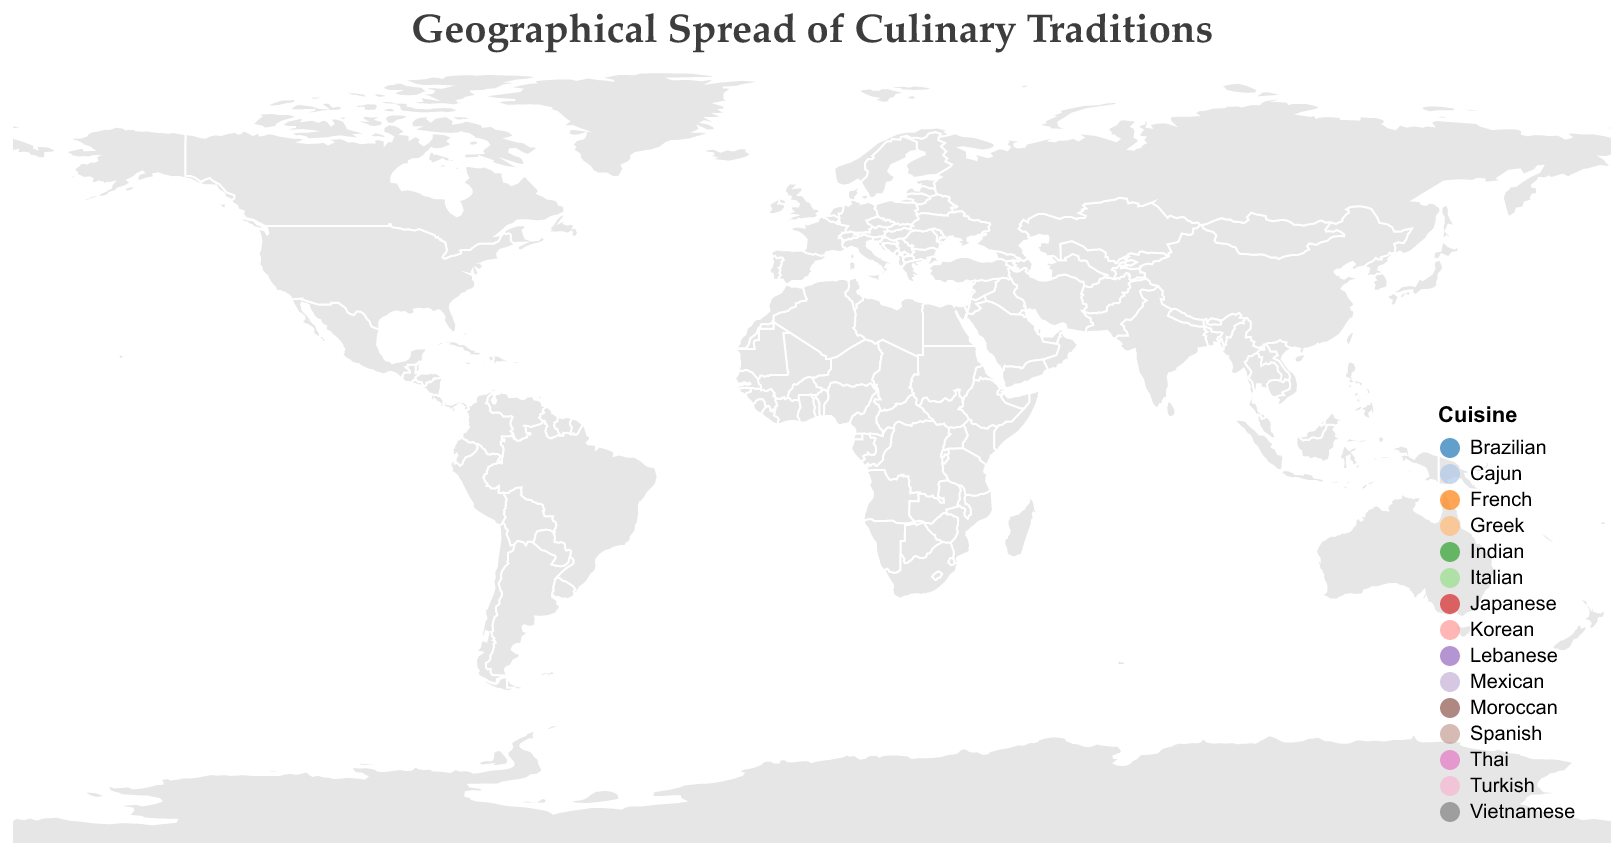How many regions are represented on the map? To determine the number of regions represented, count the unique regions listed in the data points on the map. There are 15 unique regions: New Orleans, Tuscany, Tokyo, Mumbai, Mexico City, Bangkok, Paris, Istanbul, Hanoi, Barcelona, Seoul, Beirut, Athens, Marrakech, and São Paulo.
Answer: 15 Which region has the highest comfort level? To identify the region with the highest comfort level, compare the comfort levels of all regions listed in the data. The highest comfort level is 9, which is associated with Tuscany and Paris.
Answer: Tuscany and Paris What cuisine is associated with the region that has a specialty called "Manti"? Look for the data point that mentions "Manti" as the specialty. The region is Istanbul, and the cuisine is Turkish.
Answer: Turkish Which regions have a comfort level greater than 7? To find regions with a comfort level greater than 7, filter the data points where the comfort level is greater than 7. The regions are New Orleans, Tuscany, Mexico City, Paris, Istanbul, Barcelona, Athens.
Answer: New Orleans, Tuscany, Mexico City, Paris, Istanbul, Barcelona, Athens What is the average comfort level of all the regions? To calculate the average comfort level, sum all the comfort levels and divide by the number of regions. The comfort levels are 8, 9, 7, 6, 8, 7, 9, 8, 7, 8, 6, 7, 8, 7, 6. The sum is 107, and there are 15 regions. The average is 107/15 = 7.13 (rounded to two decimal places).
Answer: 7.13 How many cuisines are shown in the legend? The legend categorizes cuisines by color. Count the unique color categories in the legend to find the number of cuisines. There are 15 cuisines as each region represents a unique cuisine.
Answer: 15 Which region's cuisine has a comfort level of 6 and is located in Asia? From the data, filter out regions in Asia with a comfort level of 6. The regions fitting this criteria are Mumbai and Seoul.
Answer: Mumbai and Seoul Which region has a specialty called "Paella"? Look for the data point that mentions "Paella" as the specialty. The region is Barcelona.
Answer: Barcelona Between Tokyo and Bangkok, which region has a higher comfort level? Compare the comfort levels of Tokyo and Bangkok from the data points. Tokyo has a comfort level of 7 and Bangkok also has a comfort level of 7. Thus, they both have equal comfort levels.
Answer: They are equal What are the specialties from regions with comfort levels of 9? To find the specialties from regions with comfort levels of 9, look at the data points for comfort level 9. The regions are Tuscany (specialty: Ribollita) and Paris (specialty: Coq au Vin).
Answer: Ribollita and Coq au Vin 